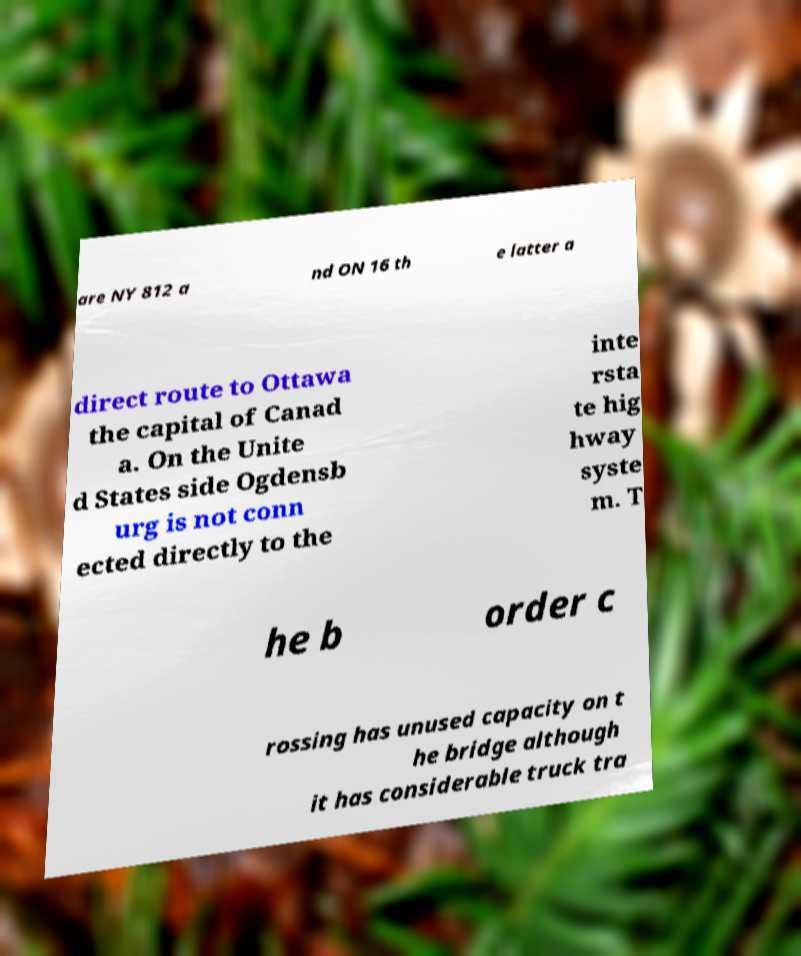There's text embedded in this image that I need extracted. Can you transcribe it verbatim? are NY 812 a nd ON 16 th e latter a direct route to Ottawa the capital of Canad a. On the Unite d States side Ogdensb urg is not conn ected directly to the inte rsta te hig hway syste m. T he b order c rossing has unused capacity on t he bridge although it has considerable truck tra 